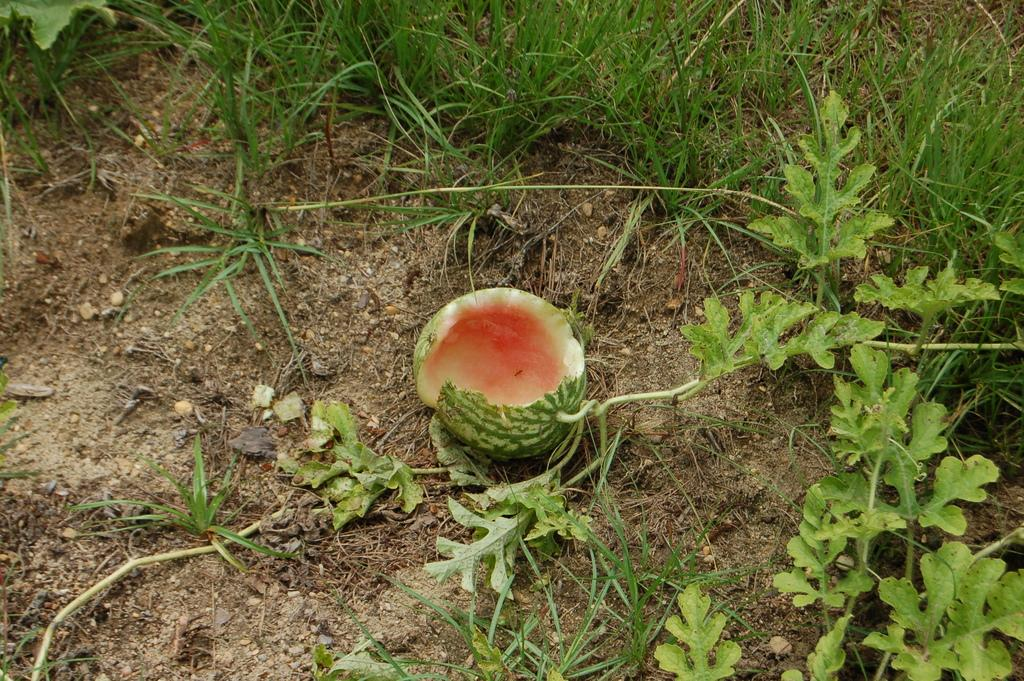What type of fruit is growing in the image? There is a watermelon on a plant in the image. What type of vegetation surrounds the watermelon? There is grass around the watermelon in the image. What type of bell can be seen hanging from the watermelon in the image? There is no bell present in the image; it features a watermelon on a plant surrounded by grass. 